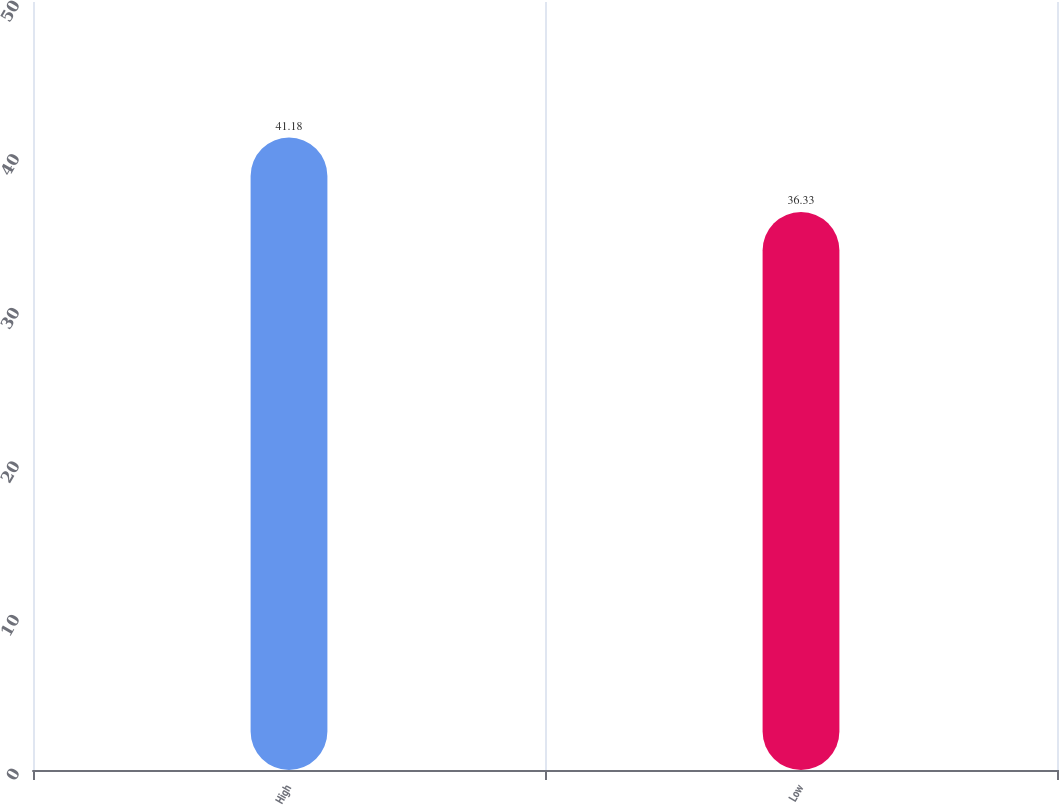<chart> <loc_0><loc_0><loc_500><loc_500><bar_chart><fcel>High<fcel>Low<nl><fcel>41.18<fcel>36.33<nl></chart> 